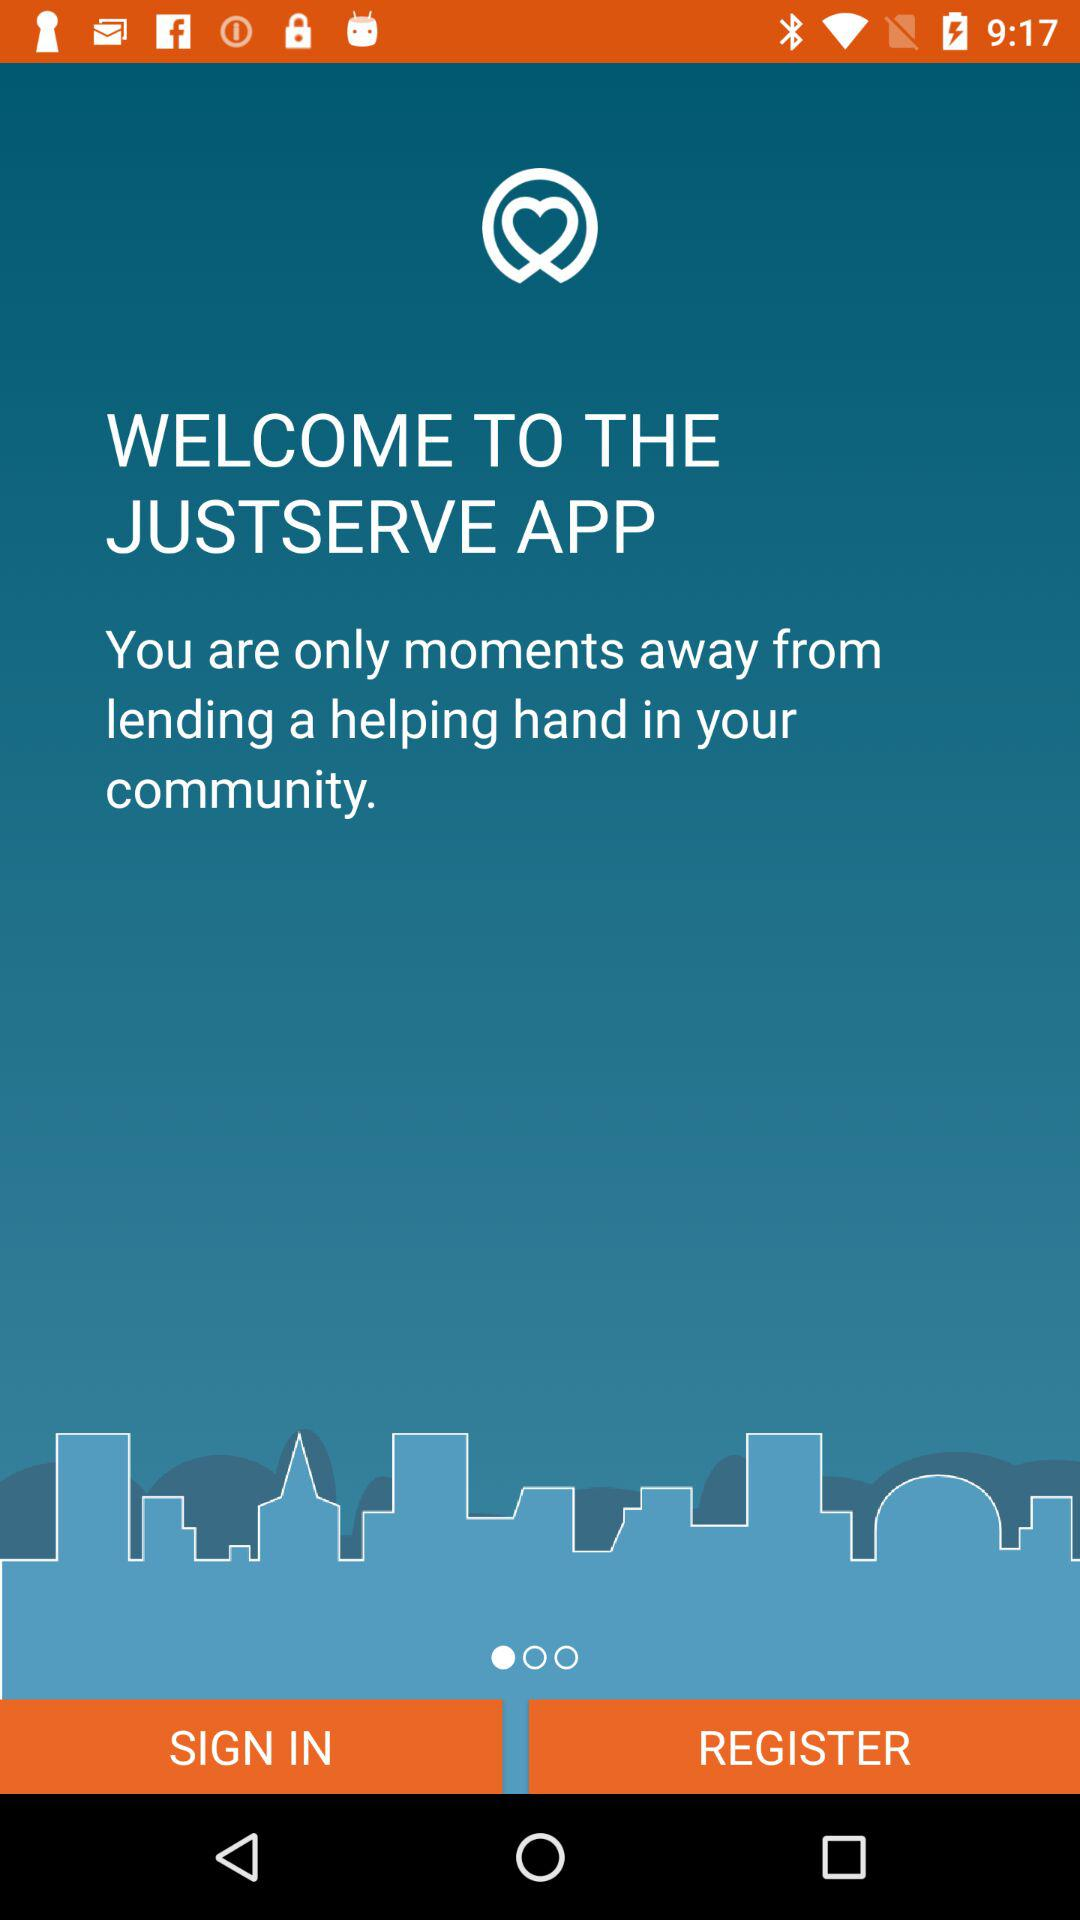What is the name of the application? The name of the application is "JUSTSERVE". 